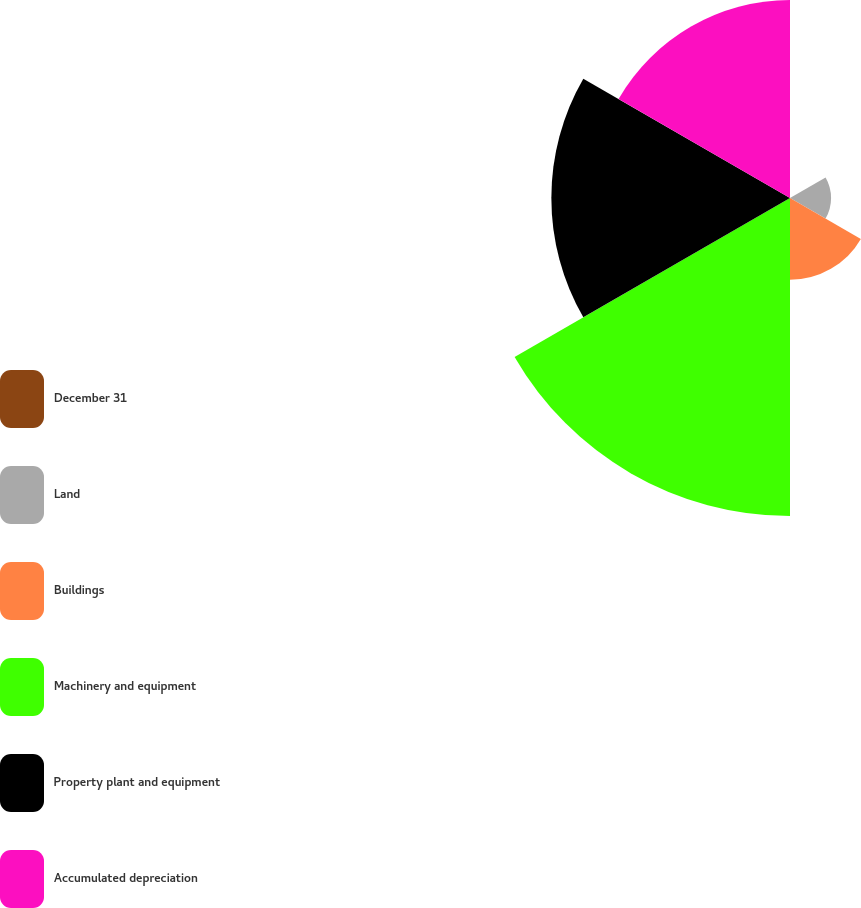<chart> <loc_0><loc_0><loc_500><loc_500><pie_chart><fcel>December 31<fcel>Land<fcel>Buildings<fcel>Machinery and equipment<fcel>Property plant and equipment<fcel>Accumulated depreciation<nl><fcel>0.03%<fcel>4.68%<fcel>9.32%<fcel>36.23%<fcel>27.19%<fcel>22.55%<nl></chart> 